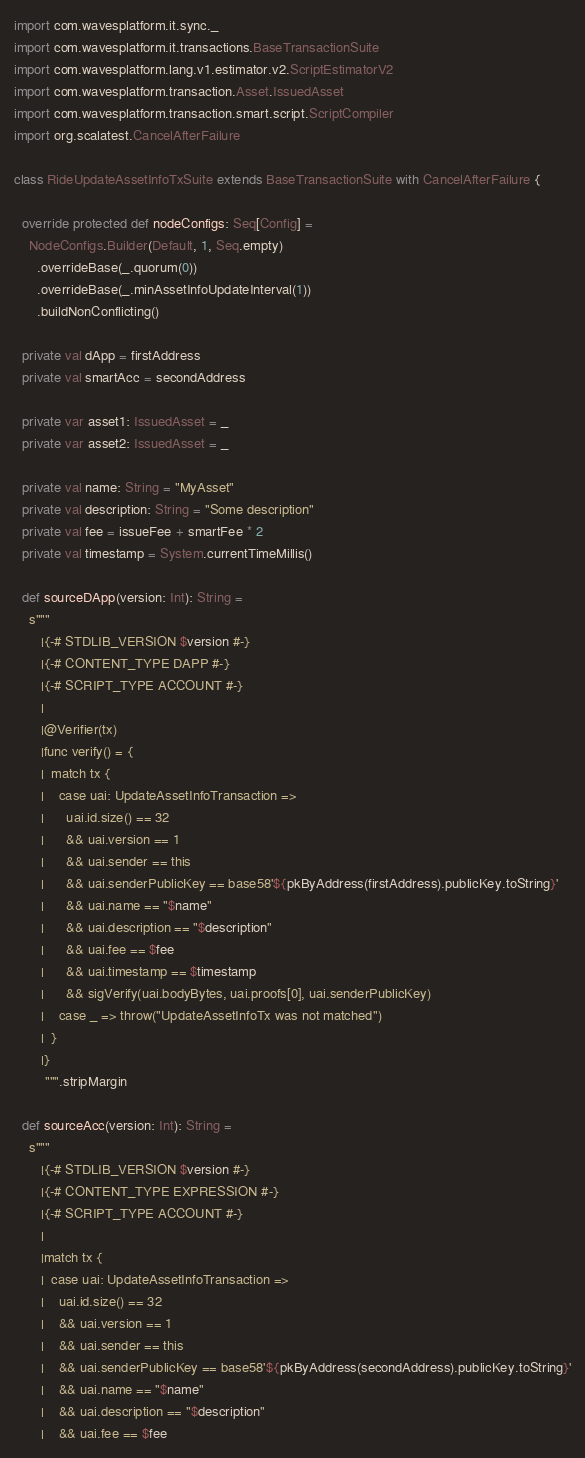Convert code to text. <code><loc_0><loc_0><loc_500><loc_500><_Scala_>import com.wavesplatform.it.sync._
import com.wavesplatform.it.transactions.BaseTransactionSuite
import com.wavesplatform.lang.v1.estimator.v2.ScriptEstimatorV2
import com.wavesplatform.transaction.Asset.IssuedAsset
import com.wavesplatform.transaction.smart.script.ScriptCompiler
import org.scalatest.CancelAfterFailure

class RideUpdateAssetInfoTxSuite extends BaseTransactionSuite with CancelAfterFailure {

  override protected def nodeConfigs: Seq[Config] =
    NodeConfigs.Builder(Default, 1, Seq.empty)
      .overrideBase(_.quorum(0))
      .overrideBase(_.minAssetInfoUpdateInterval(1))
      .buildNonConflicting()

  private val dApp = firstAddress
  private val smartAcc = secondAddress

  private var asset1: IssuedAsset = _
  private var asset2: IssuedAsset = _

  private val name: String = "MyAsset"
  private val description: String = "Some description"
  private val fee = issueFee + smartFee * 2
  private val timestamp = System.currentTimeMillis()

  def sourceDApp(version: Int): String =
    s"""
       |{-# STDLIB_VERSION $version #-}
       |{-# CONTENT_TYPE DAPP #-}
       |{-# SCRIPT_TYPE ACCOUNT #-}
       |
       |@Verifier(tx)
       |func verify() = {
       |  match tx {
       |    case uai: UpdateAssetInfoTransaction =>
       |      uai.id.size() == 32
       |      && uai.version == 1
       |      && uai.sender == this
       |      && uai.senderPublicKey == base58'${pkByAddress(firstAddress).publicKey.toString}'
       |      && uai.name == "$name"
       |      && uai.description == "$description"
       |      && uai.fee == $fee
       |      && uai.timestamp == $timestamp
       |      && sigVerify(uai.bodyBytes, uai.proofs[0], uai.senderPublicKey)
       |    case _ => throw("UpdateAssetInfoTx was not matched")
       |  }
       |}
        """.stripMargin

  def sourceAcc(version: Int): String =
    s"""
       |{-# STDLIB_VERSION $version #-}
       |{-# CONTENT_TYPE EXPRESSION #-}
       |{-# SCRIPT_TYPE ACCOUNT #-}
       |
       |match tx {
       |  case uai: UpdateAssetInfoTransaction =>
       |    uai.id.size() == 32
       |    && uai.version == 1
       |    && uai.sender == this
       |    && uai.senderPublicKey == base58'${pkByAddress(secondAddress).publicKey.toString}'
       |    && uai.name == "$name"
       |    && uai.description == "$description"
       |    && uai.fee == $fee</code> 